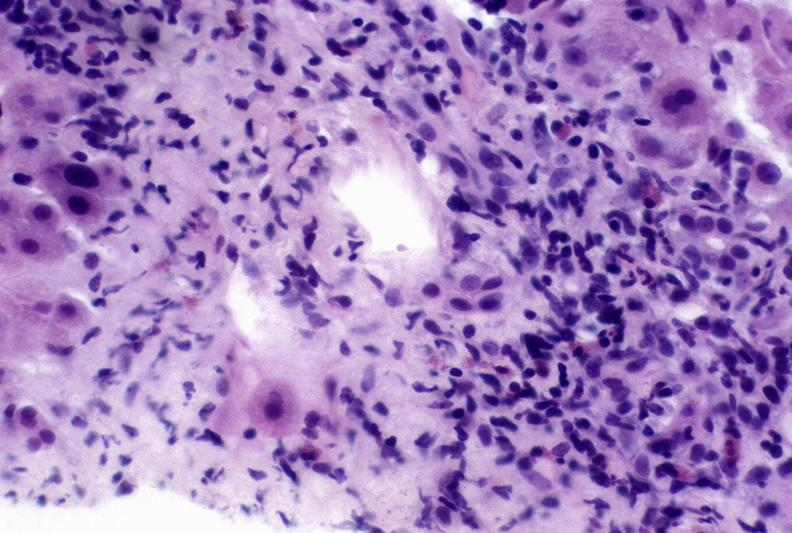s very good example present?
Answer the question using a single word or phrase. No 